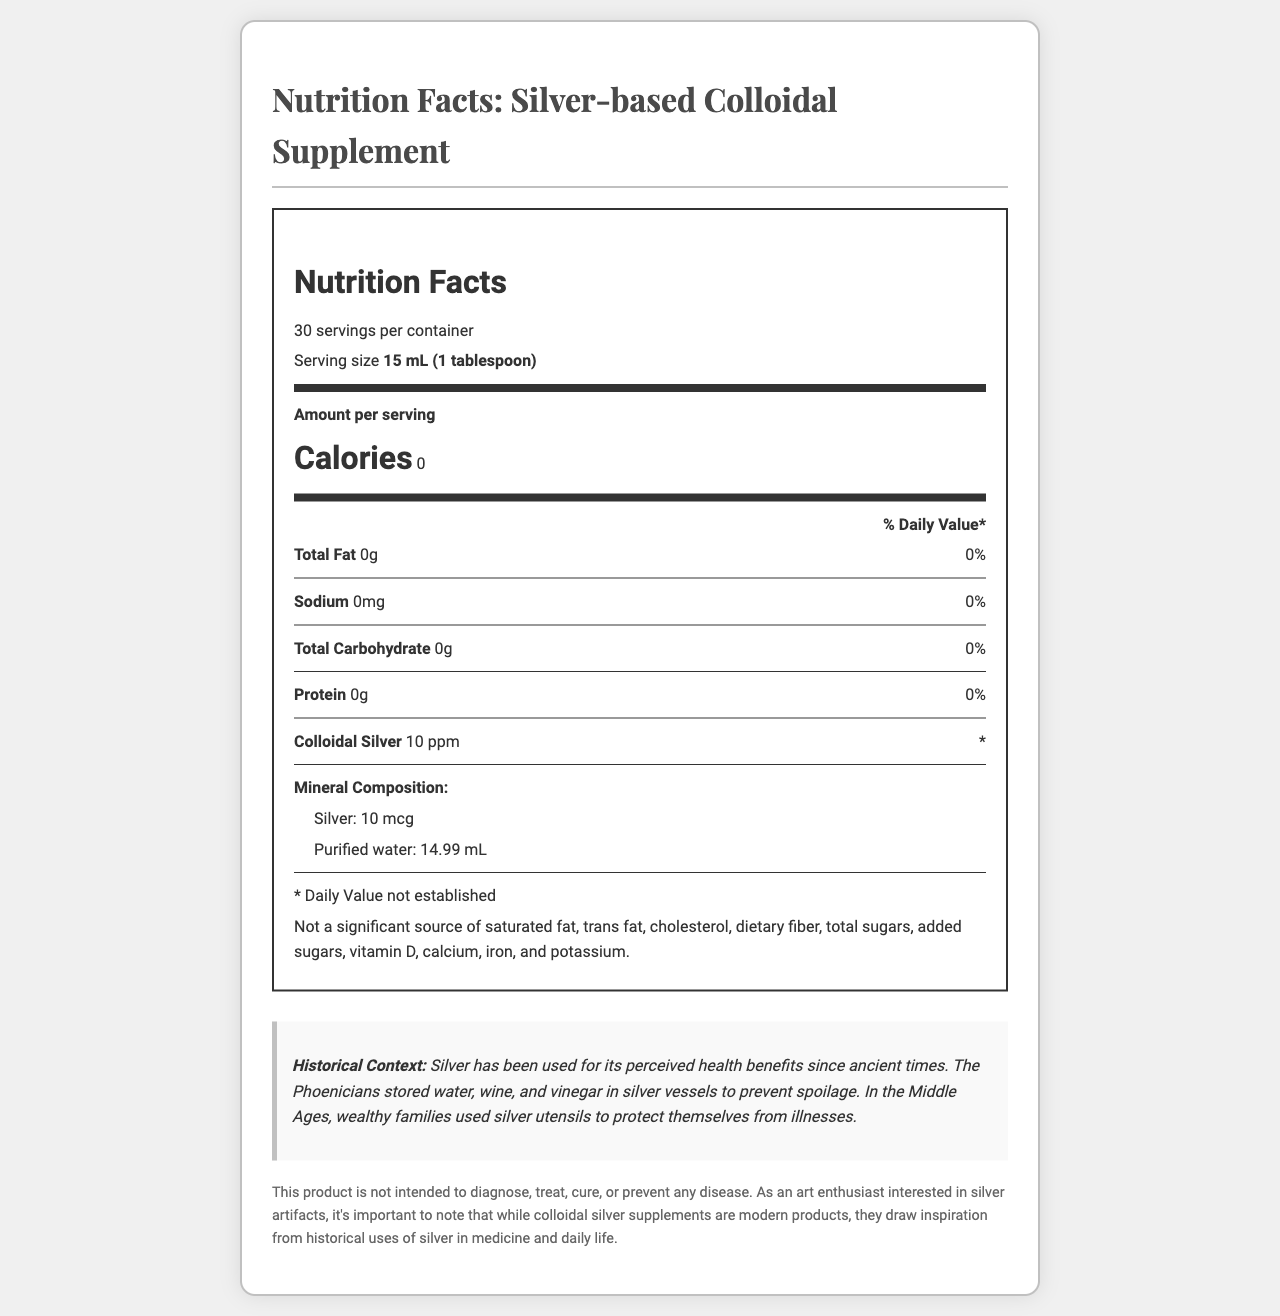what is the serving size of the supplement? The serving size is clearly listed as "15 mL (1 tablespoon)" on the document.
Answer: 15 mL (1 tablespoon) how many servings are there per container? The document states there are 30 servings per container.
Answer: 30 what are the calories per serving? The document specifies that the calories per serving are 0.
Answer: 0 what is the amount of colloidal silver per serving? The document states that each serving contains 10 ppm of colloidal silver.
Answer: 10 ppm what historical uses of silver are mentioned in the document? The historical context section in the document mentions these uses of silver.
Answer: Silver was used by the Phoenicians to store water, wine, and vinegar to prevent spoilage and by wealthy families in the Middle Ages with silver utensils to protect from illnesses. which mineral is present in the colloidal supplement? A. Gold B. Silver C. Copper D. Iron The mineral composition lists "Ionic silver particles" as an ingredient.
Answer: B. Silver what is the amount of protein per serving? The document lists the amount of protein per serving as 0g.
Answer: 0g how much purified water is in each serving? The mineral composition section lists the amount of purified water as 14.99 mL.
Answer: 14.99 mL does the document indicate that the product can treat diseases? The disclaimer explicitly states that the product is not intended to diagnose, treat, cure, or prevent any disease.
Answer: No summarize the main idea of the document The document gives detailed nutritional information about a silver-based colloidal supplement, with insights into its historical uses and a disclaimer on its intended medical use.
Answer: The document provides the nutritional facts and mineral composition of a silver-based colloidal supplement. It highlights serving size, number of servings, calories per serving, detailed nutrient breakdown, and the mineral composition. It also provides historical context about the use of silver in ancient times and includes a disclaimer about the product's intended use. how much sodium is in each serving of the supplement? The document states that each serving contains 0mg of sodium.
Answer: 0mg why did the Phoenicians use silver vessels? A. To decorate B. To preserve beauty C. To prevent spoilage D. To cook food The historical context section states that the Phoenicians used silver vessels to prevent spoilage.
Answer: C. To prevent spoilage is this product a significant source of dietary fiber? The document specifies that it is not a significant source of dietary fiber.
Answer: No what is the daily value percentage of the total carbohydrate per serving? The document lists the daily value percentage for total carbohydrate as 0%.
Answer: 0% what is the main form of silver in the supplement? The mineral composition section lists silver in the form of 'Ionic silver particles'.
Answer: Ionic silver particles why did wealthy families in the Middle Ages use silver utensils? The historical context mentions this usage of silver utensils by wealthy families in the Middle Ages.
Answer: To protect themselves from illnesses who manufactures this product? The document does not provide information about the manufacturer.
Answer: Not enough information 